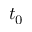<formula> <loc_0><loc_0><loc_500><loc_500>t _ { 0 }</formula> 